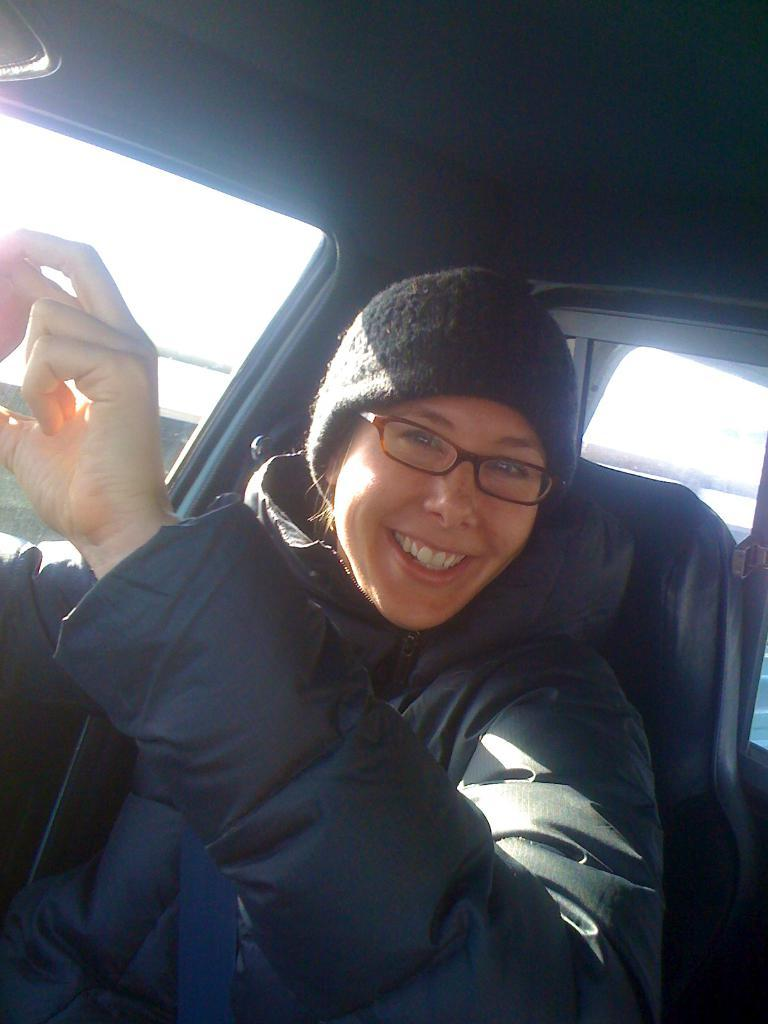Who is present in the image? There is a girl in the image. What is the girl wearing? The girl is wearing a jacket. Where is the girl located in the image? The girl is sitting in a car. What can be seen on the left side of the image? There is a window on the left side of the image. What arithmetic operation is the girl performing in the image? There is no indication in the image that the girl is performing any arithmetic operation. How many divisions are visible in the image? There are no divisions present in the image. 